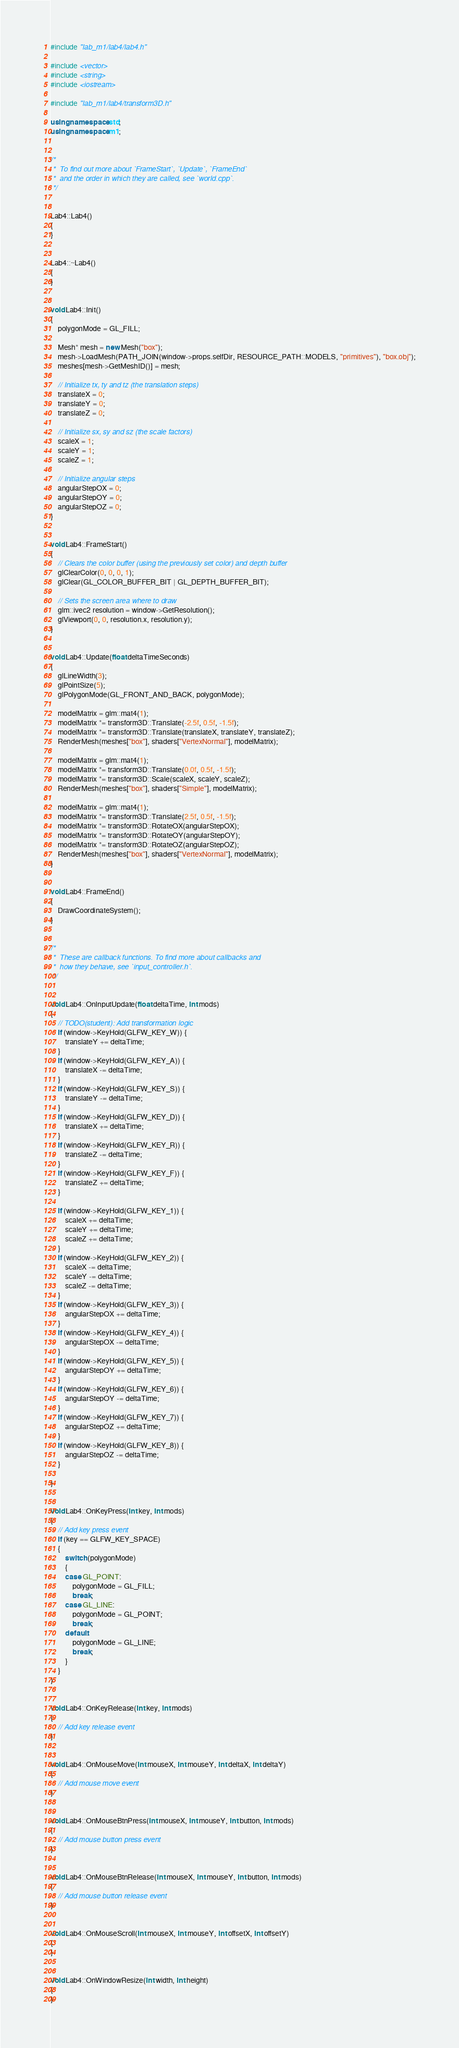<code> <loc_0><loc_0><loc_500><loc_500><_C++_>#include "lab_m1/lab4/lab4.h"

#include <vector>
#include <string>
#include <iostream>

#include "lab_m1/lab4/transform3D.h"

using namespace std;
using namespace m1;


/*
 *  To find out more about `FrameStart`, `Update`, `FrameEnd`
 *  and the order in which they are called, see `world.cpp`.
 */


Lab4::Lab4()
{
}


Lab4::~Lab4()
{
}


void Lab4::Init()
{
    polygonMode = GL_FILL;

    Mesh* mesh = new Mesh("box");
    mesh->LoadMesh(PATH_JOIN(window->props.selfDir, RESOURCE_PATH::MODELS, "primitives"), "box.obj");
    meshes[mesh->GetMeshID()] = mesh;

    // Initialize tx, ty and tz (the translation steps)
    translateX = 0;
    translateY = 0;
    translateZ = 0;

    // Initialize sx, sy and sz (the scale factors)
    scaleX = 1;
    scaleY = 1;
    scaleZ = 1;

    // Initialize angular steps
    angularStepOX = 0;
    angularStepOY = 0;
    angularStepOZ = 0;
}


void Lab4::FrameStart()
{
    // Clears the color buffer (using the previously set color) and depth buffer
    glClearColor(0, 0, 0, 1);
    glClear(GL_COLOR_BUFFER_BIT | GL_DEPTH_BUFFER_BIT);

    // Sets the screen area where to draw
    glm::ivec2 resolution = window->GetResolution();
    glViewport(0, 0, resolution.x, resolution.y);
}


void Lab4::Update(float deltaTimeSeconds)
{
    glLineWidth(3);
    glPointSize(5);
    glPolygonMode(GL_FRONT_AND_BACK, polygonMode);

    modelMatrix = glm::mat4(1);
    modelMatrix *= transform3D::Translate(-2.5f, 0.5f, -1.5f);
    modelMatrix *= transform3D::Translate(translateX, translateY, translateZ);
    RenderMesh(meshes["box"], shaders["VertexNormal"], modelMatrix);

    modelMatrix = glm::mat4(1);
    modelMatrix *= transform3D::Translate(0.0f, 0.5f, -1.5f);
    modelMatrix *= transform3D::Scale(scaleX, scaleY, scaleZ);
    RenderMesh(meshes["box"], shaders["Simple"], modelMatrix);

    modelMatrix = glm::mat4(1);
    modelMatrix *= transform3D::Translate(2.5f, 0.5f, -1.5f);
    modelMatrix *= transform3D::RotateOX(angularStepOX);
    modelMatrix *= transform3D::RotateOY(angularStepOY);
    modelMatrix *= transform3D::RotateOZ(angularStepOZ);
    RenderMesh(meshes["box"], shaders["VertexNormal"], modelMatrix);
}


void Lab4::FrameEnd()
{
    DrawCoordinateSystem();
}


/*
 *  These are callback functions. To find more about callbacks and
 *  how they behave, see `input_controller.h`.
 */


void Lab4::OnInputUpdate(float deltaTime, int mods)
{
    // TODO(student): Add transformation logic
    if (window->KeyHold(GLFW_KEY_W)) {
        translateY += deltaTime;
    }
    if (window->KeyHold(GLFW_KEY_A)) {
        translateX -= deltaTime;
    }
    if (window->KeyHold(GLFW_KEY_S)) {
        translateY -= deltaTime;
    }
    if (window->KeyHold(GLFW_KEY_D)) {
        translateX += deltaTime;
    }
    if (window->KeyHold(GLFW_KEY_R)) {
        translateZ -= deltaTime;
    }
    if (window->KeyHold(GLFW_KEY_F)) {
        translateZ += deltaTime;
    }

    if (window->KeyHold(GLFW_KEY_1)) {
        scaleX += deltaTime;
        scaleY += deltaTime;
        scaleZ += deltaTime;
    }
    if (window->KeyHold(GLFW_KEY_2)) {
        scaleX -= deltaTime;
        scaleY -= deltaTime;
        scaleZ -= deltaTime;
    }
    if (window->KeyHold(GLFW_KEY_3)) {
        angularStepOX += deltaTime;
    }
    if (window->KeyHold(GLFW_KEY_4)) {
        angularStepOX -= deltaTime;
    }
    if (window->KeyHold(GLFW_KEY_5)) {
        angularStepOY += deltaTime;
    }
    if (window->KeyHold(GLFW_KEY_6)) {
        angularStepOY -= deltaTime;
    }
    if (window->KeyHold(GLFW_KEY_7)) {
        angularStepOZ += deltaTime;
    }
    if (window->KeyHold(GLFW_KEY_8)) {
        angularStepOZ -= deltaTime;
    }
    
}


void Lab4::OnKeyPress(int key, int mods)
{
    // Add key press event
    if (key == GLFW_KEY_SPACE)
    {
        switch (polygonMode)
        {
        case GL_POINT:
            polygonMode = GL_FILL;
            break;
        case GL_LINE:
            polygonMode = GL_POINT;
            break;
        default:
            polygonMode = GL_LINE;
            break;
        }
    }
}


void Lab4::OnKeyRelease(int key, int mods)
{
    // Add key release event
}


void Lab4::OnMouseMove(int mouseX, int mouseY, int deltaX, int deltaY)
{
    // Add mouse move event
}


void Lab4::OnMouseBtnPress(int mouseX, int mouseY, int button, int mods)
{
    // Add mouse button press event
}


void Lab4::OnMouseBtnRelease(int mouseX, int mouseY, int button, int mods)
{
    // Add mouse button release event
}


void Lab4::OnMouseScroll(int mouseX, int mouseY, int offsetX, int offsetY)
{
}


void Lab4::OnWindowResize(int width, int height)
{
}
</code> 